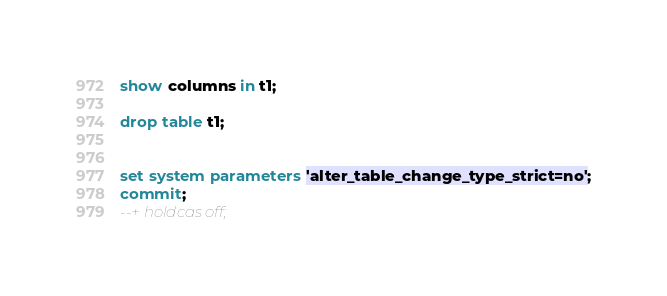Convert code to text. <code><loc_0><loc_0><loc_500><loc_500><_SQL_>show columns in t1;

drop table t1;


set system parameters 'alter_table_change_type_strict=no';
commit;
--+ holdcas off;
</code> 